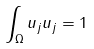<formula> <loc_0><loc_0><loc_500><loc_500>\int _ { \Omega } u _ { j } u _ { j } = 1</formula> 